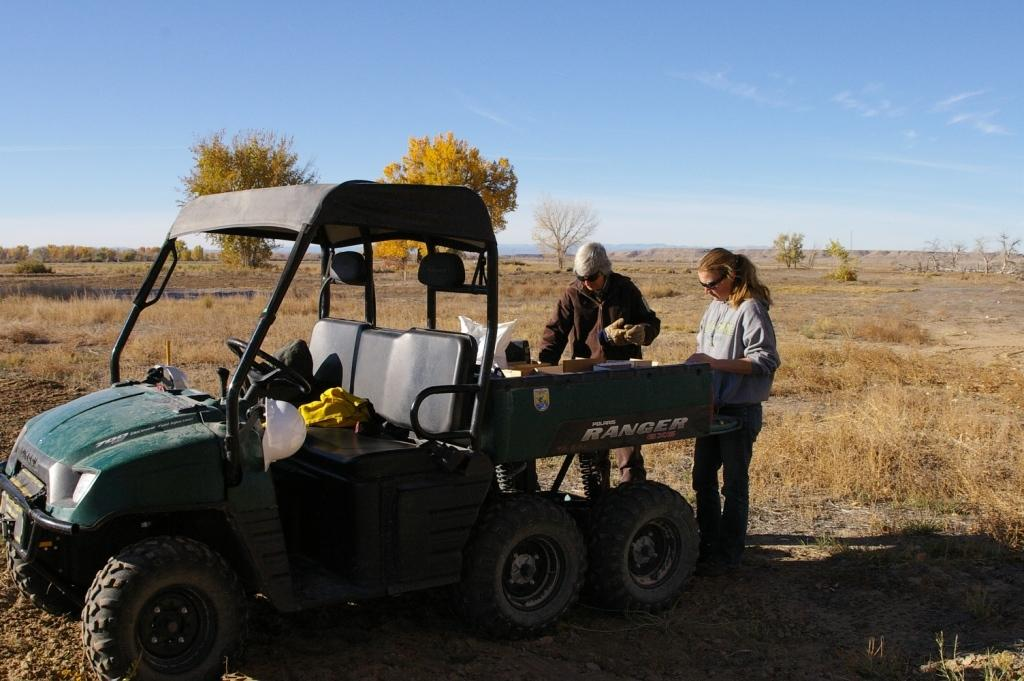What is the main subject of the picture? The main subject of the picture is a mini truck. What are the people near the mini truck doing? There are people standing near the mini truck. Can you describe what the man is holding in his hands? A man is holding something in his hands, but it is not clear what it is from the image. What type of vegetation is visible in the picture? Trees are visible in the picture, and grass is present on the ground. How would you describe the sky in the image? The sky is blue and cloudy in the image. What is the woman thinking about in the image? There is no woman present in the image, so it is not possible to determine what she might be thinking about. 